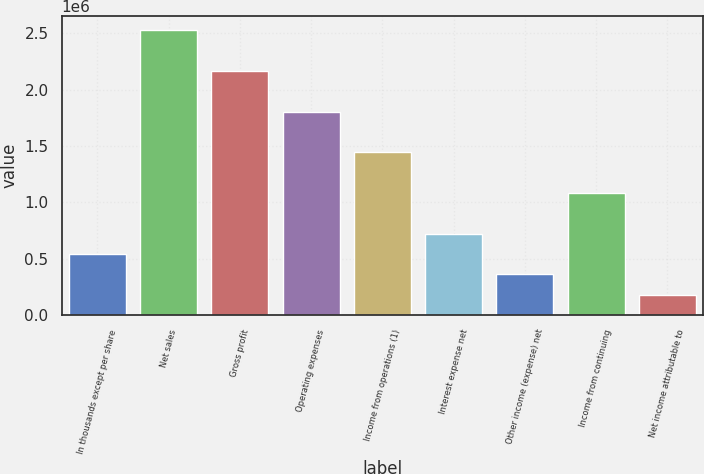<chart> <loc_0><loc_0><loc_500><loc_500><bar_chart><fcel>In thousands except per share<fcel>Net sales<fcel>Gross profit<fcel>Operating expenses<fcel>Income from operations (1)<fcel>Interest expense net<fcel>Other income (expense) net<fcel>Income from continuing<fcel>Net income attributable to<nl><fcel>540924<fcel>2.52431e+06<fcel>2.1637e+06<fcel>1.80308e+06<fcel>1.44246e+06<fcel>721232<fcel>360616<fcel>1.08185e+06<fcel>180308<nl></chart> 